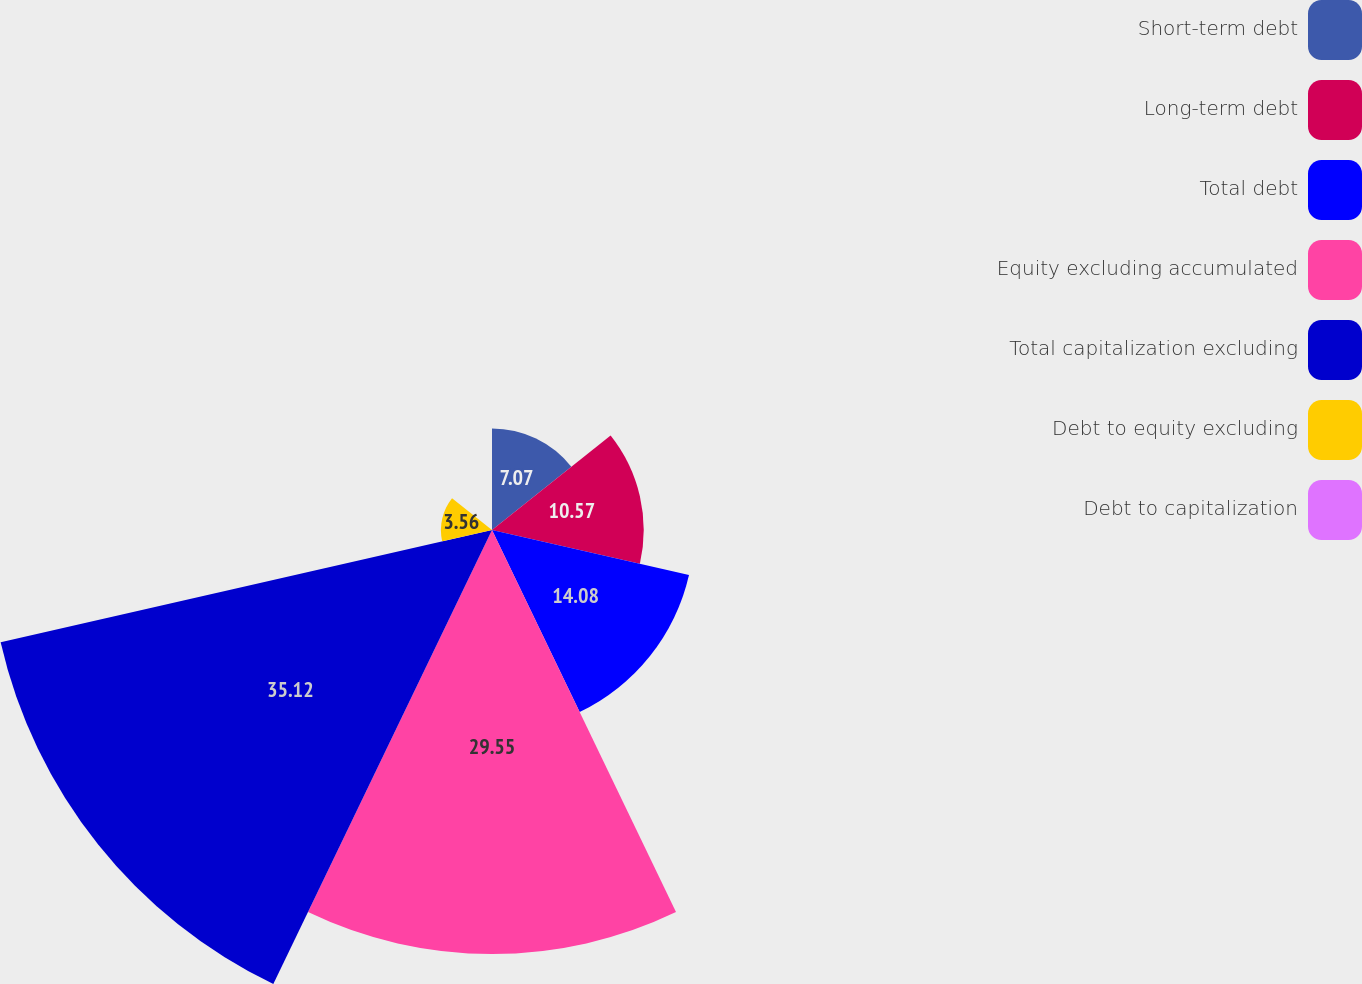Convert chart to OTSL. <chart><loc_0><loc_0><loc_500><loc_500><pie_chart><fcel>Short-term debt<fcel>Long-term debt<fcel>Total debt<fcel>Equity excluding accumulated<fcel>Total capitalization excluding<fcel>Debt to equity excluding<fcel>Debt to capitalization<nl><fcel>7.07%<fcel>10.57%<fcel>14.08%<fcel>29.55%<fcel>35.12%<fcel>3.56%<fcel>0.05%<nl></chart> 